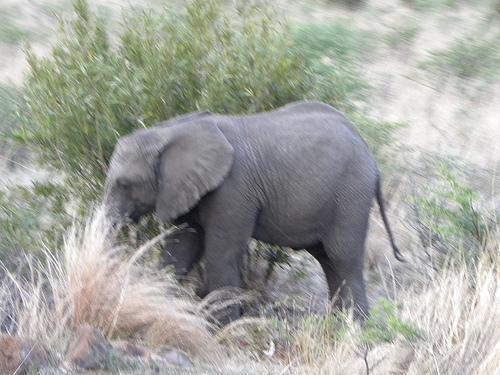How many elephants are there?
Give a very brief answer. 1. How many elephants are in the photo?
Give a very brief answer. 1. How many ears can be seen on the elephant?
Give a very brief answer. 1. How many animals are there?
Give a very brief answer. 1. 